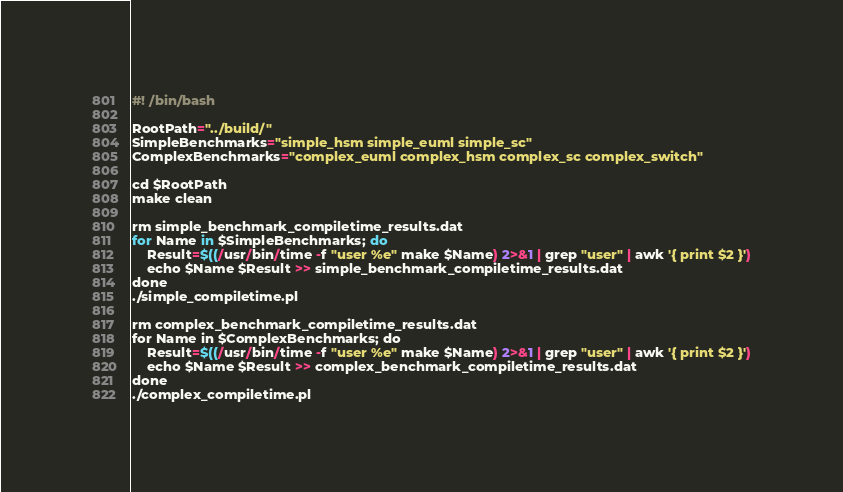Convert code to text. <code><loc_0><loc_0><loc_500><loc_500><_Bash_>#! /bin/bash

RootPath="../build/"
SimpleBenchmarks="simple_hsm simple_euml simple_sc"
ComplexBenchmarks="complex_euml complex_hsm complex_sc complex_switch"

cd $RootPath
make clean

rm simple_benchmark_compiletime_results.dat
for Name in $SimpleBenchmarks; do
    Result=$((/usr/bin/time -f "user %e" make $Name) 2>&1 | grep "user" | awk '{ print $2 }')
    echo $Name $Result >> simple_benchmark_compiletime_results.dat
done
./simple_compiletime.pl

rm complex_benchmark_compiletime_results.dat
for Name in $ComplexBenchmarks; do
    Result=$((/usr/bin/time -f "user %e" make $Name) 2>&1 | grep "user" | awk '{ print $2 }')
    echo $Name $Result >> complex_benchmark_compiletime_results.dat
done
./complex_compiletime.pl
</code> 